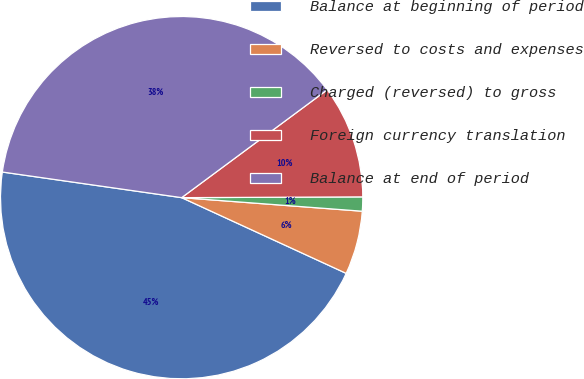Convert chart to OTSL. <chart><loc_0><loc_0><loc_500><loc_500><pie_chart><fcel>Balance at beginning of period<fcel>Reversed to costs and expenses<fcel>Charged (reversed) to gross<fcel>Foreign currency translation<fcel>Balance at end of period<nl><fcel>45.39%<fcel>5.67%<fcel>1.26%<fcel>10.08%<fcel>37.59%<nl></chart> 